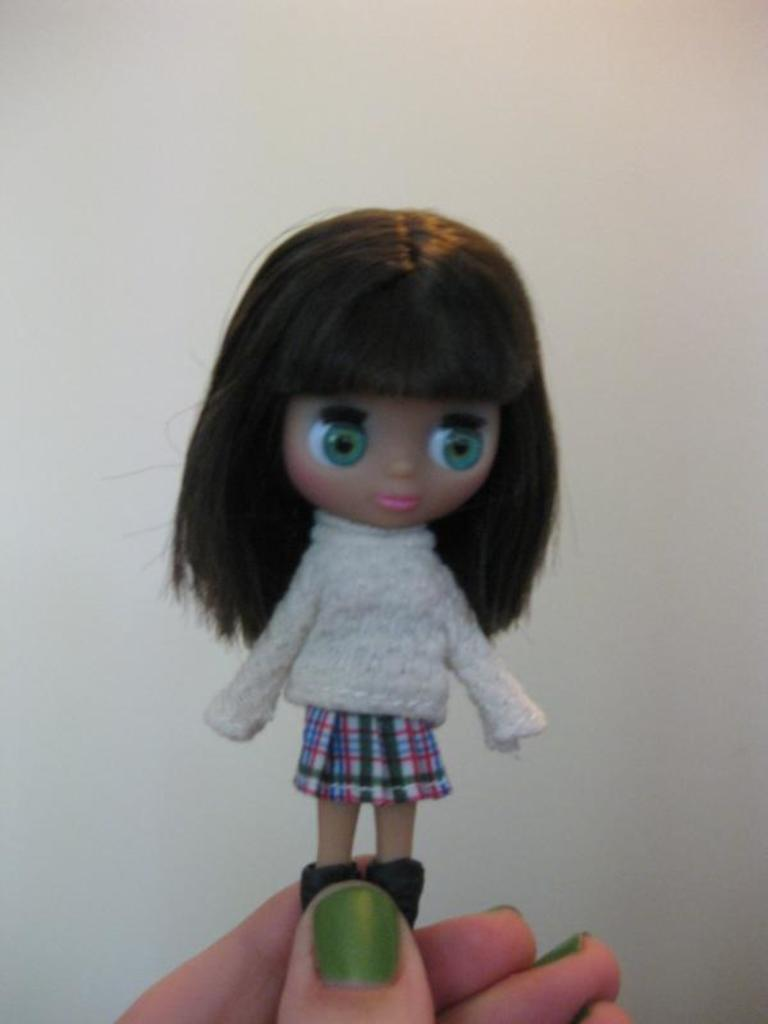What object is present in the image that is small in size? There is a small toy in the image. How is the small toy being held in the image? The toy is being held between the fingers of a person. How many rabbits are hopping around the toy in the image? There are no rabbits present in the image; it only features a small toy being held between the fingers of a person. 